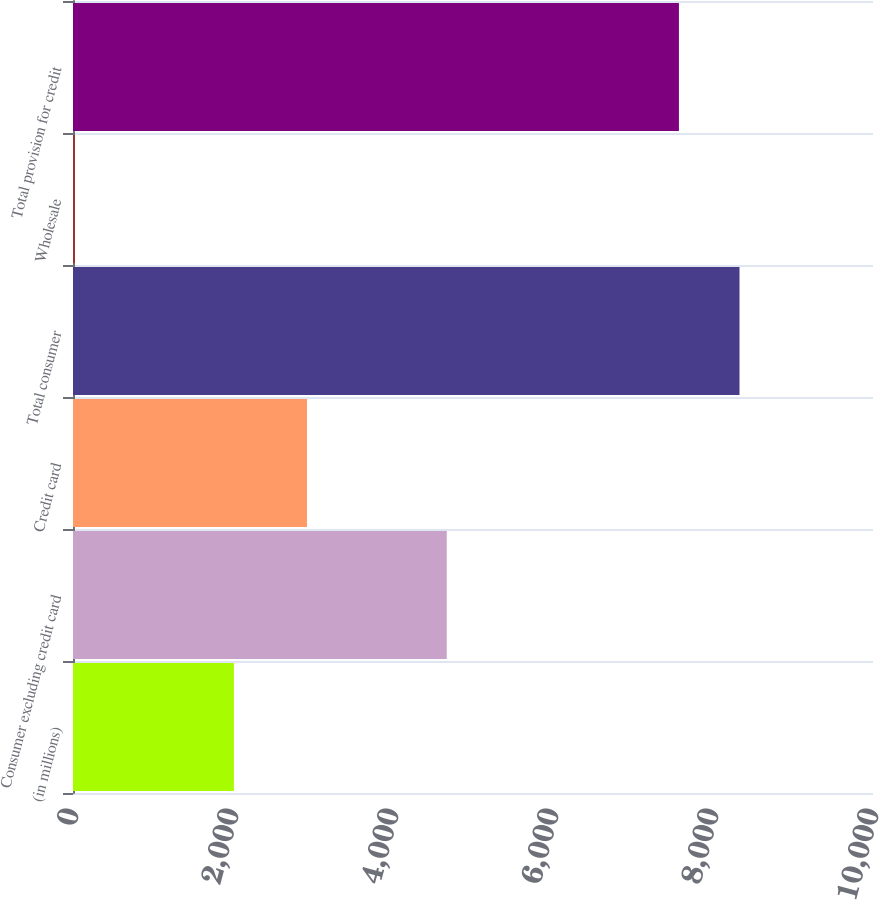<chart> <loc_0><loc_0><loc_500><loc_500><bar_chart><fcel>(in millions)<fcel>Consumer excluding credit card<fcel>Credit card<fcel>Total consumer<fcel>Wholesale<fcel>Total provision for credit<nl><fcel>2011<fcel>4672<fcel>2925<fcel>8331.4<fcel>23<fcel>7574<nl></chart> 